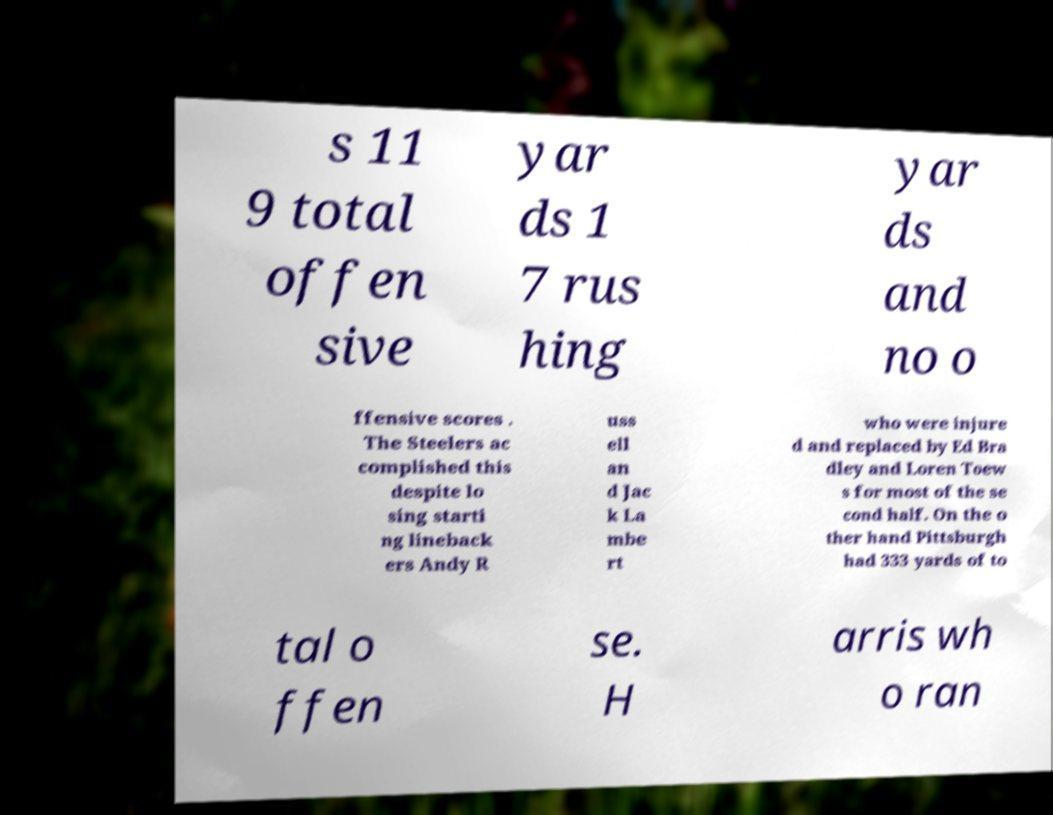Please identify and transcribe the text found in this image. s 11 9 total offen sive yar ds 1 7 rus hing yar ds and no o ffensive scores . The Steelers ac complished this despite lo sing starti ng lineback ers Andy R uss ell an d Jac k La mbe rt who were injure d and replaced by Ed Bra dley and Loren Toew s for most of the se cond half. On the o ther hand Pittsburgh had 333 yards of to tal o ffen se. H arris wh o ran 